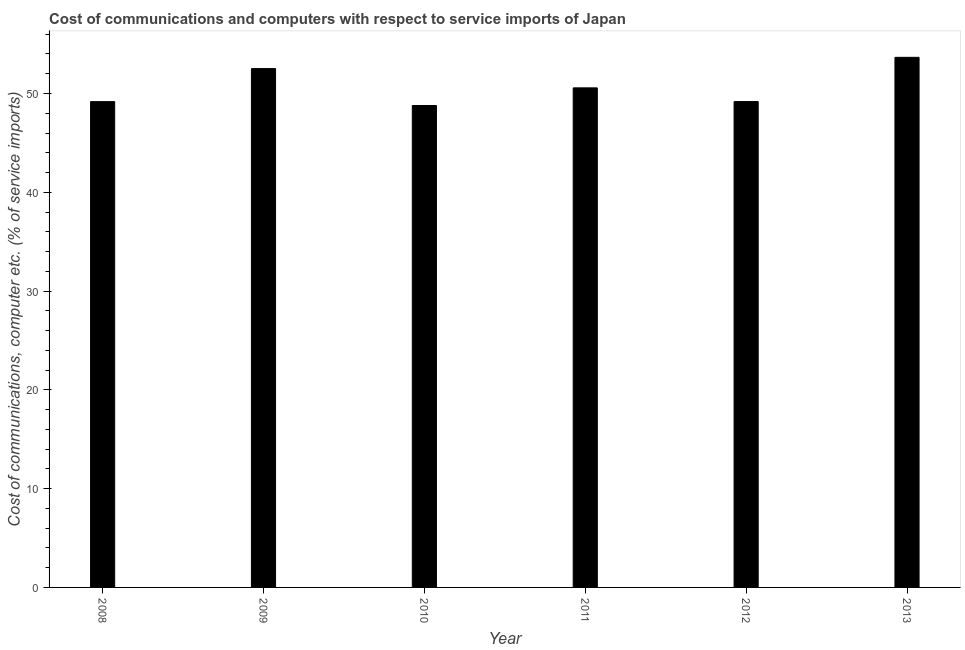Does the graph contain any zero values?
Your response must be concise. No. What is the title of the graph?
Provide a short and direct response. Cost of communications and computers with respect to service imports of Japan. What is the label or title of the X-axis?
Ensure brevity in your answer.  Year. What is the label or title of the Y-axis?
Give a very brief answer. Cost of communications, computer etc. (% of service imports). What is the cost of communications and computer in 2009?
Ensure brevity in your answer.  52.52. Across all years, what is the maximum cost of communications and computer?
Your response must be concise. 53.66. Across all years, what is the minimum cost of communications and computer?
Your response must be concise. 48.78. In which year was the cost of communications and computer minimum?
Keep it short and to the point. 2010. What is the sum of the cost of communications and computer?
Offer a very short reply. 303.89. What is the difference between the cost of communications and computer in 2009 and 2011?
Offer a terse response. 1.95. What is the average cost of communications and computer per year?
Keep it short and to the point. 50.65. What is the median cost of communications and computer?
Your response must be concise. 49.88. In how many years, is the cost of communications and computer greater than 36 %?
Give a very brief answer. 6. Is the cost of communications and computer in 2010 less than that in 2012?
Keep it short and to the point. Yes. Is the difference between the cost of communications and computer in 2008 and 2011 greater than the difference between any two years?
Your answer should be very brief. No. What is the difference between the highest and the second highest cost of communications and computer?
Offer a terse response. 1.14. Is the sum of the cost of communications and computer in 2010 and 2013 greater than the maximum cost of communications and computer across all years?
Keep it short and to the point. Yes. What is the difference between the highest and the lowest cost of communications and computer?
Give a very brief answer. 4.88. Are all the bars in the graph horizontal?
Provide a short and direct response. No. What is the difference between two consecutive major ticks on the Y-axis?
Offer a terse response. 10. What is the Cost of communications, computer etc. (% of service imports) of 2008?
Offer a very short reply. 49.18. What is the Cost of communications, computer etc. (% of service imports) of 2009?
Offer a very short reply. 52.52. What is the Cost of communications, computer etc. (% of service imports) of 2010?
Your answer should be very brief. 48.78. What is the Cost of communications, computer etc. (% of service imports) in 2011?
Offer a terse response. 50.57. What is the Cost of communications, computer etc. (% of service imports) in 2012?
Your answer should be very brief. 49.18. What is the Cost of communications, computer etc. (% of service imports) in 2013?
Give a very brief answer. 53.66. What is the difference between the Cost of communications, computer etc. (% of service imports) in 2008 and 2009?
Offer a very short reply. -3.34. What is the difference between the Cost of communications, computer etc. (% of service imports) in 2008 and 2010?
Make the answer very short. 0.39. What is the difference between the Cost of communications, computer etc. (% of service imports) in 2008 and 2011?
Give a very brief answer. -1.39. What is the difference between the Cost of communications, computer etc. (% of service imports) in 2008 and 2012?
Make the answer very short. -0.01. What is the difference between the Cost of communications, computer etc. (% of service imports) in 2008 and 2013?
Keep it short and to the point. -4.48. What is the difference between the Cost of communications, computer etc. (% of service imports) in 2009 and 2010?
Provide a succinct answer. 3.74. What is the difference between the Cost of communications, computer etc. (% of service imports) in 2009 and 2011?
Your response must be concise. 1.95. What is the difference between the Cost of communications, computer etc. (% of service imports) in 2009 and 2012?
Provide a succinct answer. 3.34. What is the difference between the Cost of communications, computer etc. (% of service imports) in 2009 and 2013?
Your answer should be compact. -1.14. What is the difference between the Cost of communications, computer etc. (% of service imports) in 2010 and 2011?
Make the answer very short. -1.79. What is the difference between the Cost of communications, computer etc. (% of service imports) in 2010 and 2012?
Offer a very short reply. -0.4. What is the difference between the Cost of communications, computer etc. (% of service imports) in 2010 and 2013?
Your answer should be very brief. -4.88. What is the difference between the Cost of communications, computer etc. (% of service imports) in 2011 and 2012?
Your response must be concise. 1.39. What is the difference between the Cost of communications, computer etc. (% of service imports) in 2011 and 2013?
Offer a terse response. -3.09. What is the difference between the Cost of communications, computer etc. (% of service imports) in 2012 and 2013?
Ensure brevity in your answer.  -4.48. What is the ratio of the Cost of communications, computer etc. (% of service imports) in 2008 to that in 2009?
Give a very brief answer. 0.94. What is the ratio of the Cost of communications, computer etc. (% of service imports) in 2008 to that in 2010?
Provide a succinct answer. 1.01. What is the ratio of the Cost of communications, computer etc. (% of service imports) in 2008 to that in 2012?
Your answer should be very brief. 1. What is the ratio of the Cost of communications, computer etc. (% of service imports) in 2008 to that in 2013?
Provide a short and direct response. 0.92. What is the ratio of the Cost of communications, computer etc. (% of service imports) in 2009 to that in 2010?
Make the answer very short. 1.08. What is the ratio of the Cost of communications, computer etc. (% of service imports) in 2009 to that in 2011?
Provide a short and direct response. 1.04. What is the ratio of the Cost of communications, computer etc. (% of service imports) in 2009 to that in 2012?
Ensure brevity in your answer.  1.07. What is the ratio of the Cost of communications, computer etc. (% of service imports) in 2010 to that in 2011?
Keep it short and to the point. 0.96. What is the ratio of the Cost of communications, computer etc. (% of service imports) in 2010 to that in 2012?
Give a very brief answer. 0.99. What is the ratio of the Cost of communications, computer etc. (% of service imports) in 2010 to that in 2013?
Keep it short and to the point. 0.91. What is the ratio of the Cost of communications, computer etc. (% of service imports) in 2011 to that in 2012?
Your answer should be compact. 1.03. What is the ratio of the Cost of communications, computer etc. (% of service imports) in 2011 to that in 2013?
Provide a succinct answer. 0.94. What is the ratio of the Cost of communications, computer etc. (% of service imports) in 2012 to that in 2013?
Your answer should be very brief. 0.92. 